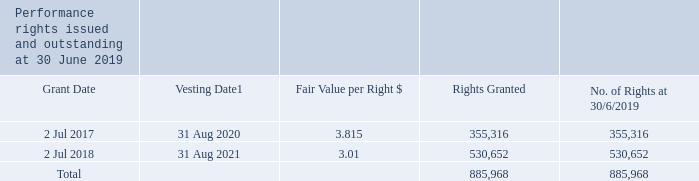B. employee performance rights plan
the employee performance rights plan (the rights plan) was approved by shareholders at the company’s agm on 23 november 2017. under the rights plan, awards are made to eligible executives and other management personnel who have an impact on the group’s performance. rights plan awards are granted in the form of performance rights over shares, which vest over a period of three years subject to meeting performance measures and continuous employment with the company. each performance right is to subscribe for one ordinary share upon vesting and, when issued, the shares will rank equally with other shares.
performance rights issued under the employee performance rights plan are valued on the same basis as those issued to kmp, which is described in note 16(d).
1. the vesting date for rights granted on 2 july 2017 and 2 july 2018 is the date on which the board notifies the executive that the rights have vested, after the outcomes for the measurement period have been determined and satisfaction of performance conditions have been assessed. this is likely to be 31 august 2020 and 31 august 2021 respectively.
no performance rights vested or lapsed during the financial year. the number of performance rights issued and outstanding at 30 june 2018 was 355,316, consisting solely of the performance rights granted on 2 july 2017.
the weighted average contractual life of outstanding performance rights at the end of the financial year is 1.77 years (2018: 2.17 years).
what is the employee performance rights plan? Awards are made to eligible executives and other management personnel who have an impact on the group’s performance. rights plan awards are granted in the form of performance rights over shares, which vest over a period of three years subject to meeting performance measures and continuous employment with the company. each performance right is to subscribe for one ordinary share upon vesting and, when issued, the shares will rank equally with other shares. What was the total number of rights granted? 885,968. How many performance rights were issued and outstanding at 30 June 2018? 355,316. What was the change in total fair value for rights granted on 2 July 2017 to 2 July 2018? (3.01 * 530,652) - (3.815 * 355,316) 
Answer: 241731.98. What was the percentage change in number of rights granted?
Answer scale should be: percent. (530,652 - 355,316) / 355,316 
Answer: 49.35. What was the total fair value for all rights granted? (3.815 * 355,316) + (3.01 * 530,652) 
Answer: 2952793.06. 